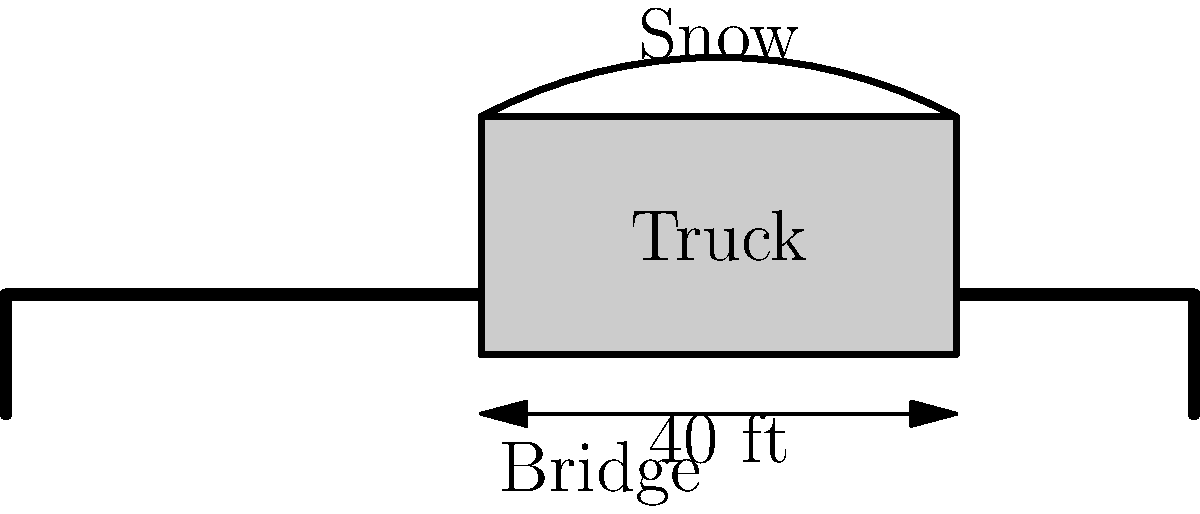You're tasked with clearing snow from a local bridge after a heavy storm. The bridge has a posted weight limit of 30 tons. Your snow plow truck weighs 15 tons when empty. If the bridge is 100 feet long and 40 feet wide, and the snow depth is uniformly 2 feet, what is the maximum distance the truck can safely plow before exceeding the bridge's weight capacity? Assume the density of the snow is 15 lbs/ft³. Let's approach this step-by-step:

1) First, calculate the weight of snow on the entire bridge:
   - Volume of snow = Length × Width × Depth
   - Volume = 100 ft × 40 ft × 2 ft = 8,000 ft³
   - Weight of snow = Volume × Density
   - Weight = 8,000 ft³ × 15 lbs/ft³ = 120,000 lbs = 60 tons

2) Calculate the available weight capacity:
   - Bridge capacity = 30 tons
   - Truck weight = 15 tons
   - Available capacity = 30 tons - 15 tons = 15 tons

3) Calculate the weight of snow per foot of bridge length:
   - Snow weight per foot = Total snow weight ÷ Bridge length
   - Snow weight per foot = 60 tons ÷ 100 ft = 0.6 tons/ft

4) Calculate the maximum distance the truck can plow:
   - Max distance = Available capacity ÷ Snow weight per foot
   - Max distance = 15 tons ÷ 0.6 tons/ft = 25 ft

Therefore, the truck can safely plow up to 25 feet of the bridge before exceeding the weight limit.
Answer: 25 feet 